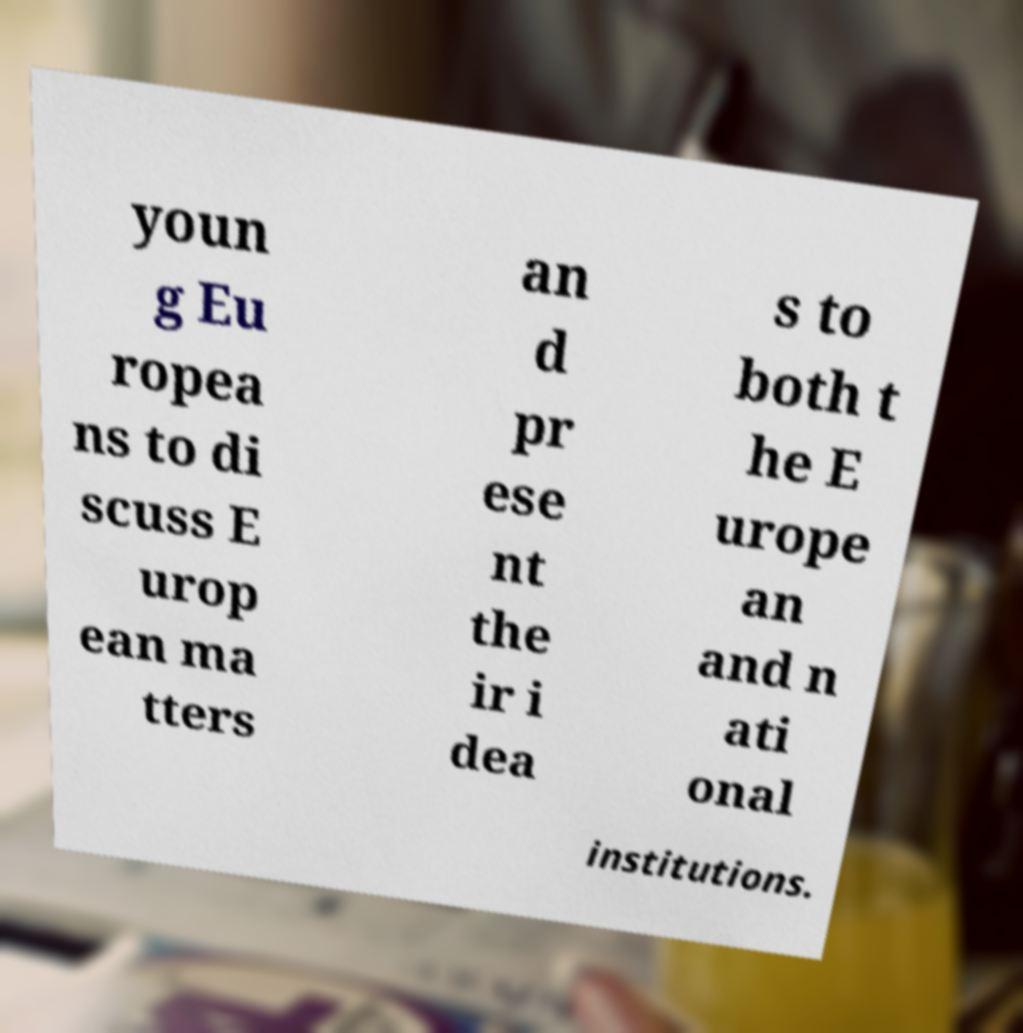There's text embedded in this image that I need extracted. Can you transcribe it verbatim? youn g Eu ropea ns to di scuss E urop ean ma tters an d pr ese nt the ir i dea s to both t he E urope an and n ati onal institutions. 